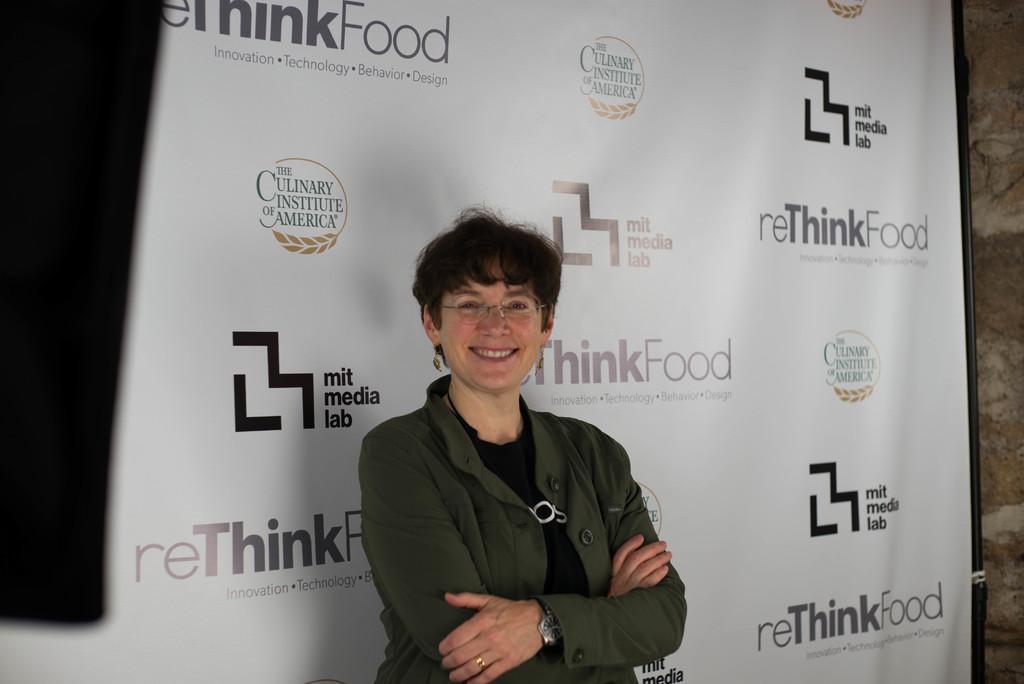Please provide a concise description of this image. In this picture I can see there is a woman standing, she is wearing a coat, spectacles and she is smiling. There is a banner in the backdrop and there is something written on it. 